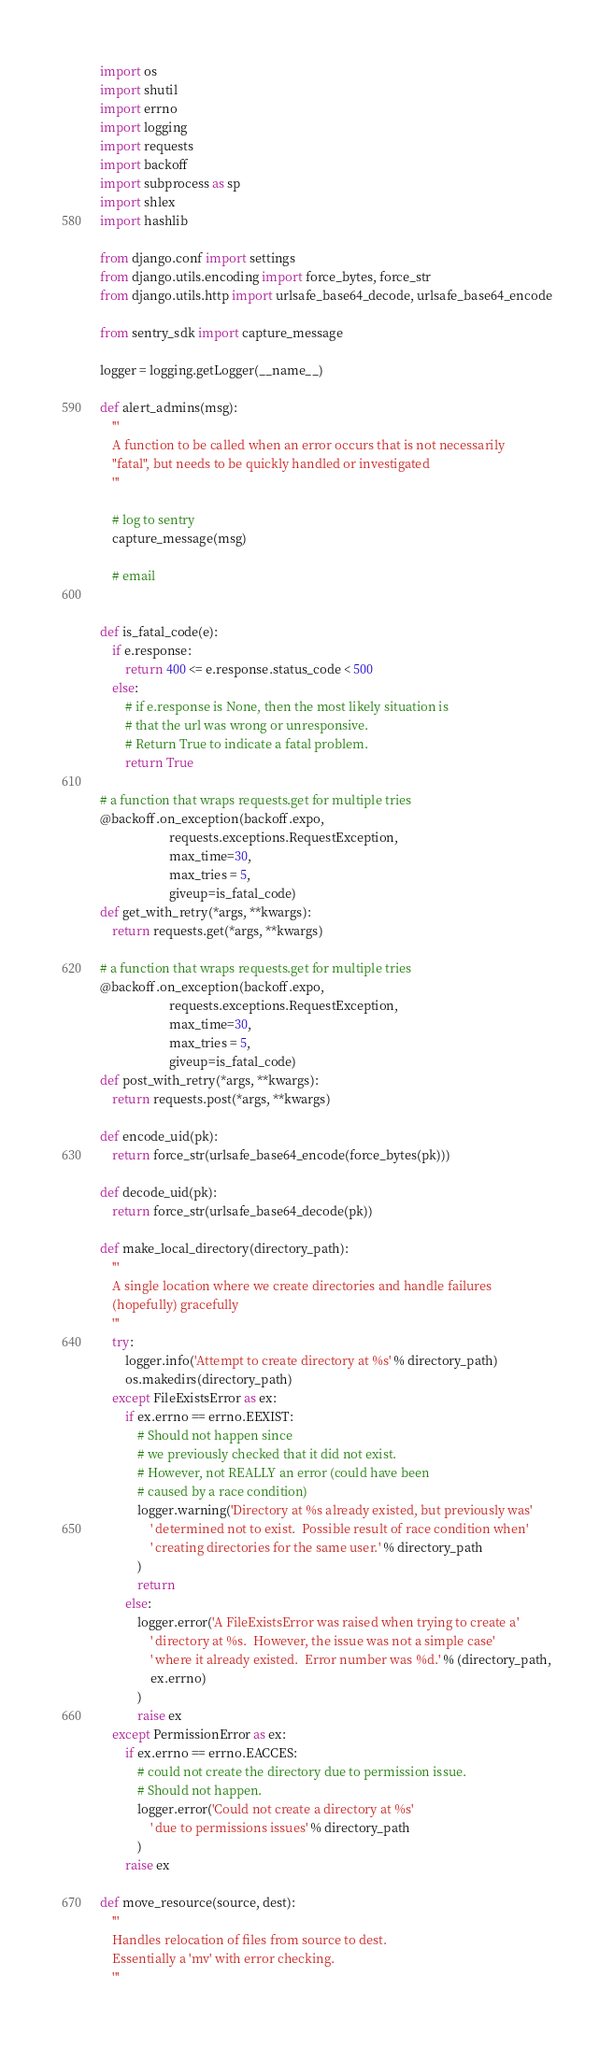<code> <loc_0><loc_0><loc_500><loc_500><_Python_>import os
import shutil
import errno
import logging
import requests
import backoff
import subprocess as sp
import shlex
import hashlib

from django.conf import settings
from django.utils.encoding import force_bytes, force_str
from django.utils.http import urlsafe_base64_decode, urlsafe_base64_encode

from sentry_sdk import capture_message

logger = logging.getLogger(__name__)

def alert_admins(msg):
    '''
    A function to be called when an error occurs that is not necessarily
    "fatal", but needs to be quickly handled or investigated
    '''

    # log to sentry
    capture_message(msg)

    # email


def is_fatal_code(e):
    if e.response:
        return 400 <= e.response.status_code < 500
    else:
        # if e.response is None, then the most likely situation is
        # that the url was wrong or unresponsive.
        # Return True to indicate a fatal problem.
        return True

# a function that wraps requests.get for multiple tries
@backoff.on_exception(backoff.expo,
                      requests.exceptions.RequestException,
                      max_time=30,
                      max_tries = 5,
                      giveup=is_fatal_code)
def get_with_retry(*args, **kwargs):
    return requests.get(*args, **kwargs)

# a function that wraps requests.get for multiple tries
@backoff.on_exception(backoff.expo,
                      requests.exceptions.RequestException,
                      max_time=30,
                      max_tries = 5,
                      giveup=is_fatal_code)
def post_with_retry(*args, **kwargs):
    return requests.post(*args, **kwargs)

def encode_uid(pk):
    return force_str(urlsafe_base64_encode(force_bytes(pk)))

def decode_uid(pk):
    return force_str(urlsafe_base64_decode(pk))

def make_local_directory(directory_path):
    '''
    A single location where we create directories and handle failures
    (hopefully) gracefully
    '''
    try:
        logger.info('Attempt to create directory at %s' % directory_path)
        os.makedirs(directory_path)
    except FileExistsError as ex:
        if ex.errno == errno.EEXIST:
            # Should not happen since
            # we previously checked that it did not exist.
            # However, not REALLY an error (could have been
            # caused by a race condition)
            logger.warning('Directory at %s already existed, but previously was'
                ' determined not to exist.  Possible result of race condition when'
                ' creating directories for the same user.' % directory_path
            )
            return 
        else:
            logger.error('A FileExistsError was raised when trying to create a'
                ' directory at %s.  However, the issue was not a simple case'
                ' where it already existed.  Error number was %d.' % (directory_path,
                ex.errno)
            )
            raise ex
    except PermissionError as ex:
        if ex.errno == errno.EACCES:
            # could not create the directory due to permission issue.
            # Should not happen.  
            logger.error('Could not create a directory at %s'
                ' due to permissions issues' % directory_path
            )
        raise ex

def move_resource(source, dest):
    '''
    Handles relocation of files from source to dest.
    Essentially a 'mv' with error checking.
    '''
</code> 